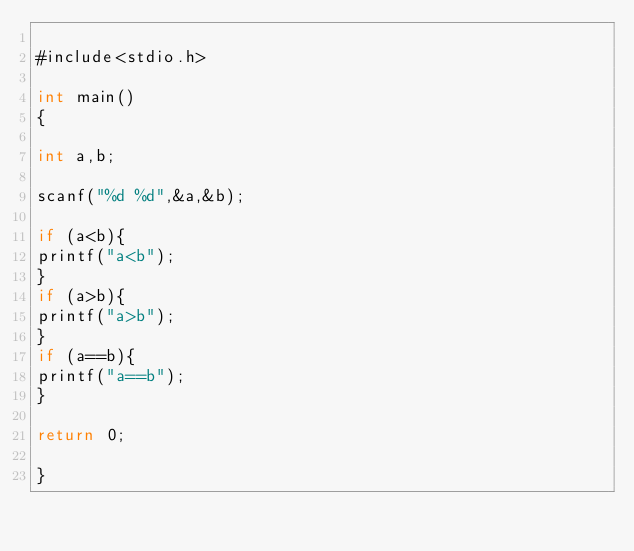<code> <loc_0><loc_0><loc_500><loc_500><_C#_>
#include<stdio.h>
 
int main()
{
 
int a,b;
 
scanf("%d %d",&a,&b);
 
if (a<b){
printf("a<b");
}
if (a>b){
printf("a>b");
}
if (a==b){
printf("a==b");
}
 
return 0;
 
}
</code> 